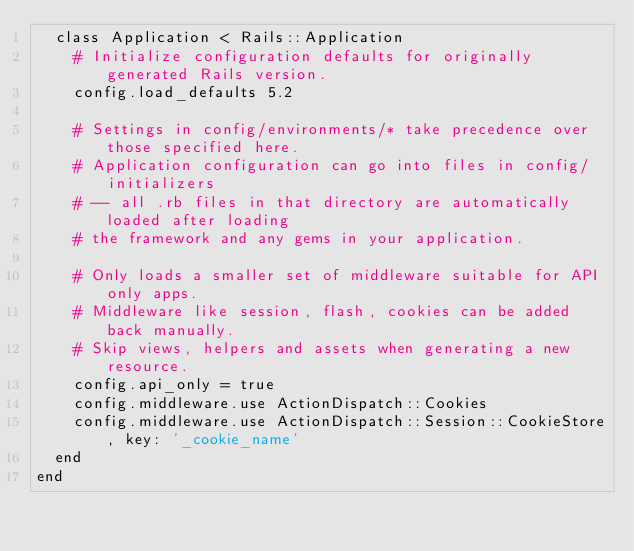Convert code to text. <code><loc_0><loc_0><loc_500><loc_500><_Ruby_>  class Application < Rails::Application
    # Initialize configuration defaults for originally generated Rails version.
    config.load_defaults 5.2

    # Settings in config/environments/* take precedence over those specified here.
    # Application configuration can go into files in config/initializers
    # -- all .rb files in that directory are automatically loaded after loading
    # the framework and any gems in your application.

    # Only loads a smaller set of middleware suitable for API only apps.
    # Middleware like session, flash, cookies can be added back manually.
    # Skip views, helpers and assets when generating a new resource.
    config.api_only = true
    config.middleware.use ActionDispatch::Cookies
    config.middleware.use ActionDispatch::Session::CookieStore, key: '_cookie_name'
  end
end
</code> 